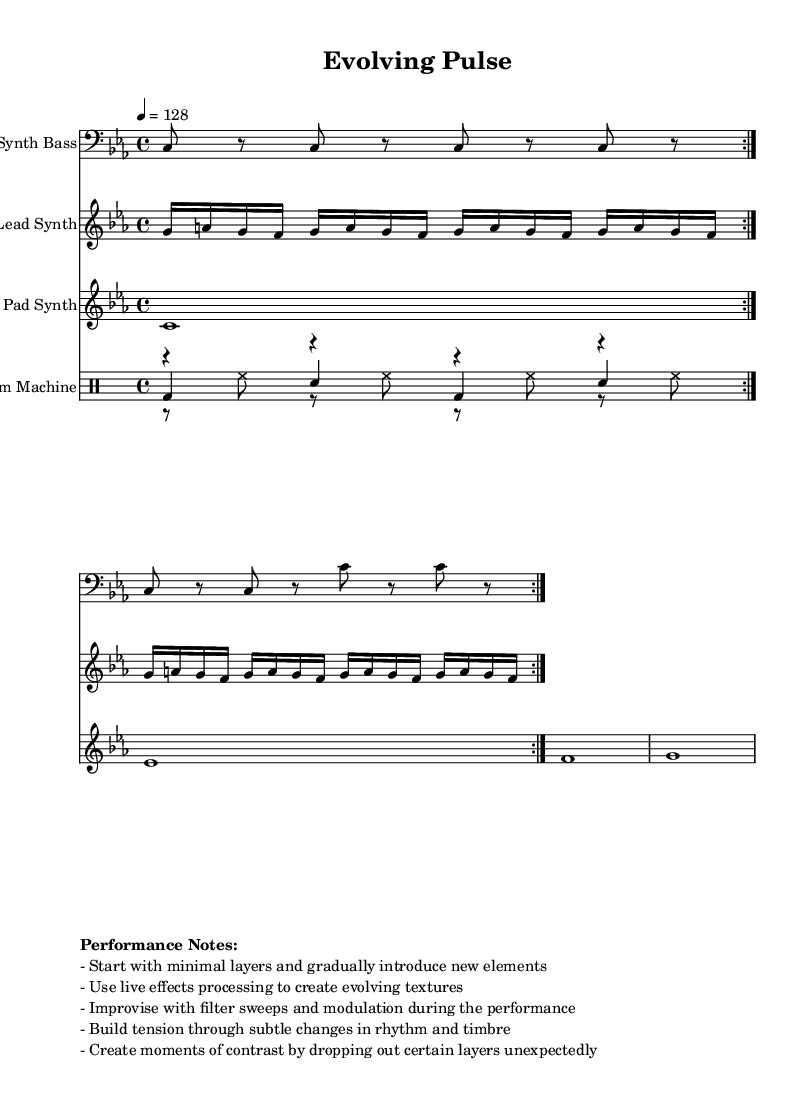What is the key signature of this music? The key signature is found at the beginning of the staff and indicates C minor, which has three flats (B, E, and A).
Answer: C minor What is the time signature of this music? The time signature is located at the start of the score, noted as 4/4, meaning there are four beats per measure.
Answer: 4/4 What is the tempo marking of this piece? The tempo marking is indicated by "4 = 128" which means the quarter note receives 128 beats per minute.
Answer: 128 How many measures are there in the kick drum part? The kick drum part consists of a repeated section that contains a set number of bars. Each repeat has two measures, and since it repeats twice, there are four measures total.
Answer: 4 What is the rhythmic pattern of the hi-hat? The hi-hat part consists of eighth notes played in a regular pattern, indicated by the sequence of rests and hi-hat hits.
Answer: Eighth notes What elements contribute to creating tension in the performance? The performance notes indicate that tension can be built through subtle changes in rhythm and timbre, as well as improvisation and live effects processing.
Answer: Rhythm and timbre Which voice is used for the pad synth in this score? The pad synth is shown on a separate staff and uses whole notes, making it the harmonic anchor of the piece.
Answer: Whole notes 